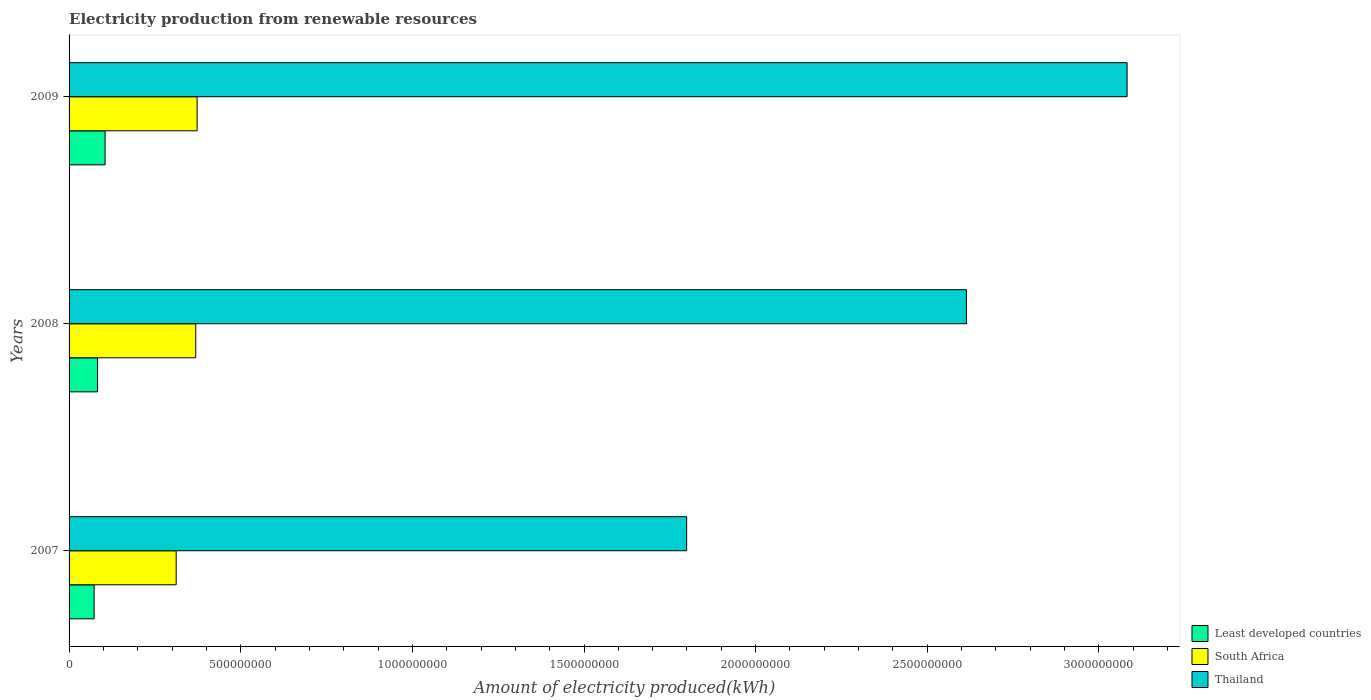Are the number of bars per tick equal to the number of legend labels?
Offer a very short reply. Yes. Are the number of bars on each tick of the Y-axis equal?
Keep it short and to the point. Yes. How many bars are there on the 1st tick from the top?
Offer a terse response. 3. What is the amount of electricity produced in Least developed countries in 2009?
Provide a succinct answer. 1.05e+08. Across all years, what is the maximum amount of electricity produced in Thailand?
Your response must be concise. 3.08e+09. Across all years, what is the minimum amount of electricity produced in Thailand?
Provide a short and direct response. 1.80e+09. In which year was the amount of electricity produced in Least developed countries minimum?
Offer a very short reply. 2007. What is the total amount of electricity produced in South Africa in the graph?
Your answer should be very brief. 1.05e+09. What is the difference between the amount of electricity produced in South Africa in 2008 and that in 2009?
Your answer should be compact. -4.00e+06. What is the difference between the amount of electricity produced in South Africa in 2009 and the amount of electricity produced in Thailand in 2008?
Give a very brief answer. -2.24e+09. What is the average amount of electricity produced in Thailand per year?
Provide a succinct answer. 2.50e+09. In the year 2009, what is the difference between the amount of electricity produced in Thailand and amount of electricity produced in South Africa?
Your answer should be very brief. 2.71e+09. What is the ratio of the amount of electricity produced in Least developed countries in 2007 to that in 2008?
Make the answer very short. 0.88. Is the amount of electricity produced in Thailand in 2008 less than that in 2009?
Keep it short and to the point. Yes. What is the difference between the highest and the lowest amount of electricity produced in Least developed countries?
Your answer should be very brief. 3.20e+07. In how many years, is the amount of electricity produced in South Africa greater than the average amount of electricity produced in South Africa taken over all years?
Your answer should be compact. 2. What does the 1st bar from the top in 2008 represents?
Make the answer very short. Thailand. What does the 3rd bar from the bottom in 2008 represents?
Your answer should be very brief. Thailand. Is it the case that in every year, the sum of the amount of electricity produced in Thailand and amount of electricity produced in South Africa is greater than the amount of electricity produced in Least developed countries?
Provide a short and direct response. Yes. Are all the bars in the graph horizontal?
Give a very brief answer. Yes. What is the difference between two consecutive major ticks on the X-axis?
Make the answer very short. 5.00e+08. Are the values on the major ticks of X-axis written in scientific E-notation?
Offer a very short reply. No. Does the graph contain grids?
Offer a terse response. No. Where does the legend appear in the graph?
Provide a short and direct response. Bottom right. How many legend labels are there?
Make the answer very short. 3. How are the legend labels stacked?
Provide a short and direct response. Vertical. What is the title of the graph?
Ensure brevity in your answer.  Electricity production from renewable resources. Does "Lithuania" appear as one of the legend labels in the graph?
Ensure brevity in your answer.  No. What is the label or title of the X-axis?
Offer a very short reply. Amount of electricity produced(kWh). What is the Amount of electricity produced(kWh) of Least developed countries in 2007?
Offer a terse response. 7.30e+07. What is the Amount of electricity produced(kWh) of South Africa in 2007?
Offer a terse response. 3.12e+08. What is the Amount of electricity produced(kWh) in Thailand in 2007?
Provide a short and direct response. 1.80e+09. What is the Amount of electricity produced(kWh) in Least developed countries in 2008?
Make the answer very short. 8.30e+07. What is the Amount of electricity produced(kWh) in South Africa in 2008?
Provide a short and direct response. 3.69e+08. What is the Amount of electricity produced(kWh) of Thailand in 2008?
Give a very brief answer. 2.61e+09. What is the Amount of electricity produced(kWh) in Least developed countries in 2009?
Your answer should be compact. 1.05e+08. What is the Amount of electricity produced(kWh) in South Africa in 2009?
Give a very brief answer. 3.73e+08. What is the Amount of electricity produced(kWh) in Thailand in 2009?
Your answer should be very brief. 3.08e+09. Across all years, what is the maximum Amount of electricity produced(kWh) in Least developed countries?
Offer a terse response. 1.05e+08. Across all years, what is the maximum Amount of electricity produced(kWh) of South Africa?
Keep it short and to the point. 3.73e+08. Across all years, what is the maximum Amount of electricity produced(kWh) of Thailand?
Give a very brief answer. 3.08e+09. Across all years, what is the minimum Amount of electricity produced(kWh) of Least developed countries?
Your answer should be very brief. 7.30e+07. Across all years, what is the minimum Amount of electricity produced(kWh) in South Africa?
Provide a succinct answer. 3.12e+08. Across all years, what is the minimum Amount of electricity produced(kWh) in Thailand?
Make the answer very short. 1.80e+09. What is the total Amount of electricity produced(kWh) of Least developed countries in the graph?
Ensure brevity in your answer.  2.61e+08. What is the total Amount of electricity produced(kWh) of South Africa in the graph?
Keep it short and to the point. 1.05e+09. What is the total Amount of electricity produced(kWh) in Thailand in the graph?
Give a very brief answer. 7.50e+09. What is the difference between the Amount of electricity produced(kWh) in Least developed countries in 2007 and that in 2008?
Provide a succinct answer. -1.00e+07. What is the difference between the Amount of electricity produced(kWh) of South Africa in 2007 and that in 2008?
Your response must be concise. -5.70e+07. What is the difference between the Amount of electricity produced(kWh) in Thailand in 2007 and that in 2008?
Make the answer very short. -8.15e+08. What is the difference between the Amount of electricity produced(kWh) in Least developed countries in 2007 and that in 2009?
Keep it short and to the point. -3.20e+07. What is the difference between the Amount of electricity produced(kWh) of South Africa in 2007 and that in 2009?
Make the answer very short. -6.10e+07. What is the difference between the Amount of electricity produced(kWh) in Thailand in 2007 and that in 2009?
Make the answer very short. -1.28e+09. What is the difference between the Amount of electricity produced(kWh) of Least developed countries in 2008 and that in 2009?
Ensure brevity in your answer.  -2.20e+07. What is the difference between the Amount of electricity produced(kWh) in Thailand in 2008 and that in 2009?
Provide a short and direct response. -4.68e+08. What is the difference between the Amount of electricity produced(kWh) of Least developed countries in 2007 and the Amount of electricity produced(kWh) of South Africa in 2008?
Your answer should be very brief. -2.96e+08. What is the difference between the Amount of electricity produced(kWh) of Least developed countries in 2007 and the Amount of electricity produced(kWh) of Thailand in 2008?
Give a very brief answer. -2.54e+09. What is the difference between the Amount of electricity produced(kWh) in South Africa in 2007 and the Amount of electricity produced(kWh) in Thailand in 2008?
Offer a terse response. -2.30e+09. What is the difference between the Amount of electricity produced(kWh) of Least developed countries in 2007 and the Amount of electricity produced(kWh) of South Africa in 2009?
Your response must be concise. -3.00e+08. What is the difference between the Amount of electricity produced(kWh) in Least developed countries in 2007 and the Amount of electricity produced(kWh) in Thailand in 2009?
Your answer should be compact. -3.01e+09. What is the difference between the Amount of electricity produced(kWh) in South Africa in 2007 and the Amount of electricity produced(kWh) in Thailand in 2009?
Ensure brevity in your answer.  -2.77e+09. What is the difference between the Amount of electricity produced(kWh) of Least developed countries in 2008 and the Amount of electricity produced(kWh) of South Africa in 2009?
Your answer should be very brief. -2.90e+08. What is the difference between the Amount of electricity produced(kWh) in Least developed countries in 2008 and the Amount of electricity produced(kWh) in Thailand in 2009?
Offer a very short reply. -3.00e+09. What is the difference between the Amount of electricity produced(kWh) of South Africa in 2008 and the Amount of electricity produced(kWh) of Thailand in 2009?
Give a very brief answer. -2.71e+09. What is the average Amount of electricity produced(kWh) in Least developed countries per year?
Your answer should be compact. 8.70e+07. What is the average Amount of electricity produced(kWh) in South Africa per year?
Offer a very short reply. 3.51e+08. What is the average Amount of electricity produced(kWh) of Thailand per year?
Offer a terse response. 2.50e+09. In the year 2007, what is the difference between the Amount of electricity produced(kWh) in Least developed countries and Amount of electricity produced(kWh) in South Africa?
Offer a terse response. -2.39e+08. In the year 2007, what is the difference between the Amount of electricity produced(kWh) of Least developed countries and Amount of electricity produced(kWh) of Thailand?
Give a very brief answer. -1.73e+09. In the year 2007, what is the difference between the Amount of electricity produced(kWh) in South Africa and Amount of electricity produced(kWh) in Thailand?
Give a very brief answer. -1.49e+09. In the year 2008, what is the difference between the Amount of electricity produced(kWh) of Least developed countries and Amount of electricity produced(kWh) of South Africa?
Give a very brief answer. -2.86e+08. In the year 2008, what is the difference between the Amount of electricity produced(kWh) in Least developed countries and Amount of electricity produced(kWh) in Thailand?
Your answer should be very brief. -2.53e+09. In the year 2008, what is the difference between the Amount of electricity produced(kWh) of South Africa and Amount of electricity produced(kWh) of Thailand?
Offer a terse response. -2.24e+09. In the year 2009, what is the difference between the Amount of electricity produced(kWh) in Least developed countries and Amount of electricity produced(kWh) in South Africa?
Your answer should be very brief. -2.68e+08. In the year 2009, what is the difference between the Amount of electricity produced(kWh) of Least developed countries and Amount of electricity produced(kWh) of Thailand?
Your answer should be very brief. -2.98e+09. In the year 2009, what is the difference between the Amount of electricity produced(kWh) in South Africa and Amount of electricity produced(kWh) in Thailand?
Offer a very short reply. -2.71e+09. What is the ratio of the Amount of electricity produced(kWh) in Least developed countries in 2007 to that in 2008?
Your answer should be compact. 0.88. What is the ratio of the Amount of electricity produced(kWh) in South Africa in 2007 to that in 2008?
Make the answer very short. 0.85. What is the ratio of the Amount of electricity produced(kWh) in Thailand in 2007 to that in 2008?
Keep it short and to the point. 0.69. What is the ratio of the Amount of electricity produced(kWh) of Least developed countries in 2007 to that in 2009?
Keep it short and to the point. 0.7. What is the ratio of the Amount of electricity produced(kWh) of South Africa in 2007 to that in 2009?
Give a very brief answer. 0.84. What is the ratio of the Amount of electricity produced(kWh) in Thailand in 2007 to that in 2009?
Provide a short and direct response. 0.58. What is the ratio of the Amount of electricity produced(kWh) of Least developed countries in 2008 to that in 2009?
Your response must be concise. 0.79. What is the ratio of the Amount of electricity produced(kWh) in South Africa in 2008 to that in 2009?
Your response must be concise. 0.99. What is the ratio of the Amount of electricity produced(kWh) in Thailand in 2008 to that in 2009?
Ensure brevity in your answer.  0.85. What is the difference between the highest and the second highest Amount of electricity produced(kWh) of Least developed countries?
Provide a succinct answer. 2.20e+07. What is the difference between the highest and the second highest Amount of electricity produced(kWh) of South Africa?
Give a very brief answer. 4.00e+06. What is the difference between the highest and the second highest Amount of electricity produced(kWh) of Thailand?
Keep it short and to the point. 4.68e+08. What is the difference between the highest and the lowest Amount of electricity produced(kWh) in Least developed countries?
Your answer should be compact. 3.20e+07. What is the difference between the highest and the lowest Amount of electricity produced(kWh) of South Africa?
Provide a succinct answer. 6.10e+07. What is the difference between the highest and the lowest Amount of electricity produced(kWh) of Thailand?
Provide a short and direct response. 1.28e+09. 